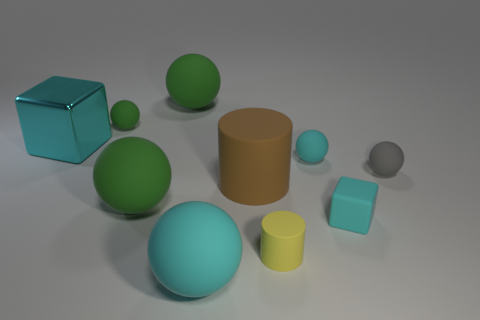Subtract all gray spheres. How many spheres are left? 5 Subtract 1 cubes. How many cubes are left? 1 Subtract all cylinders. How many objects are left? 8 Subtract all green cylinders. How many blue cubes are left? 0 Subtract all big matte cylinders. Subtract all cyan cubes. How many objects are left? 7 Add 4 small matte cubes. How many small matte cubes are left? 5 Add 8 small cyan blocks. How many small cyan blocks exist? 9 Subtract all brown cylinders. How many cylinders are left? 1 Subtract 0 purple cubes. How many objects are left? 10 Subtract all brown spheres. Subtract all blue cubes. How many spheres are left? 6 